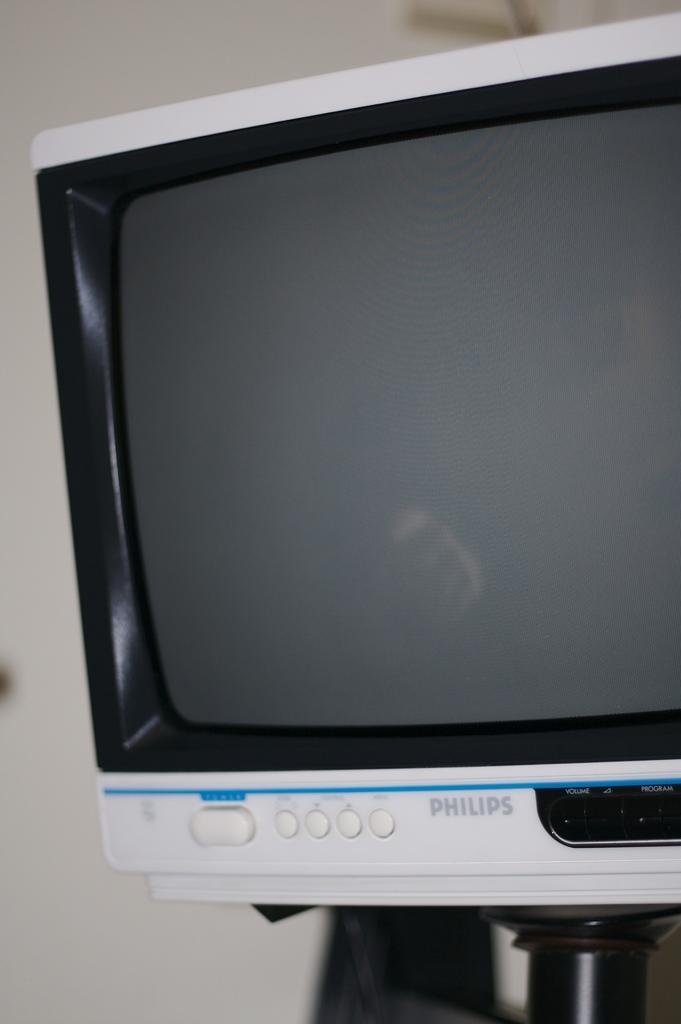Could you give a brief overview of what you see in this image? In this picture we can observe a television which is in white color. In the background we can observe a white color wall. 